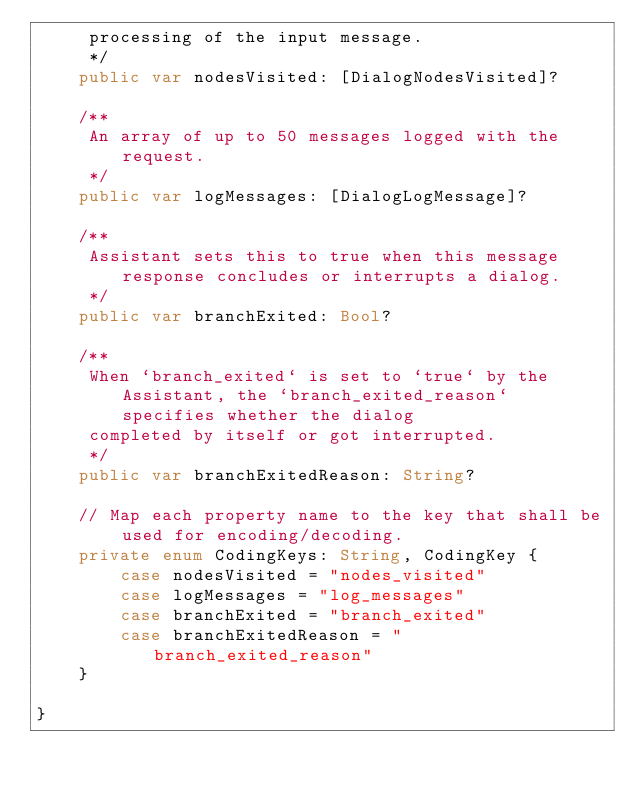Convert code to text. <code><loc_0><loc_0><loc_500><loc_500><_Swift_>     processing of the input message.
     */
    public var nodesVisited: [DialogNodesVisited]?

    /**
     An array of up to 50 messages logged with the request.
     */
    public var logMessages: [DialogLogMessage]?

    /**
     Assistant sets this to true when this message response concludes or interrupts a dialog.
     */
    public var branchExited: Bool?

    /**
     When `branch_exited` is set to `true` by the Assistant, the `branch_exited_reason` specifies whether the dialog
     completed by itself or got interrupted.
     */
    public var branchExitedReason: String?

    // Map each property name to the key that shall be used for encoding/decoding.
    private enum CodingKeys: String, CodingKey {
        case nodesVisited = "nodes_visited"
        case logMessages = "log_messages"
        case branchExited = "branch_exited"
        case branchExitedReason = "branch_exited_reason"
    }

}
</code> 